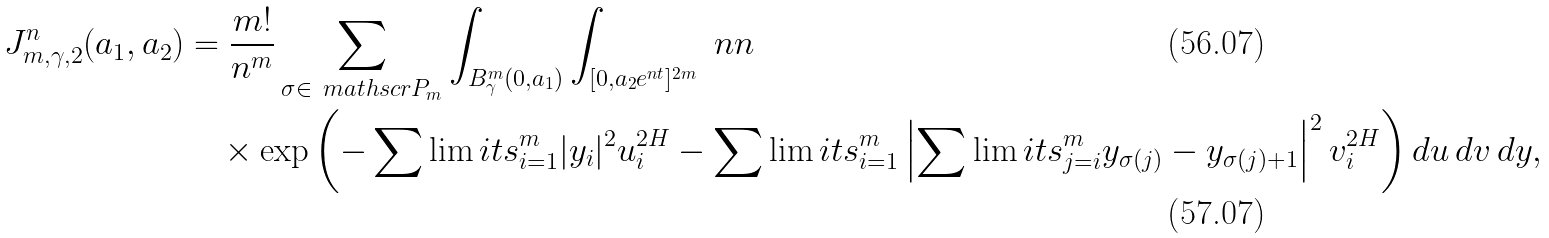Convert formula to latex. <formula><loc_0><loc_0><loc_500><loc_500>\ J ^ { n } _ { m , \gamma , 2 } ( a _ { 1 } , a _ { 2 } ) & = \frac { m ! } { n ^ { m } } \sum _ { \sigma \in \ m a t h s c r { P } _ { m } } \int _ { B ^ { m } _ { \gamma } ( 0 , a _ { 1 } ) } \int _ { [ 0 , a _ { 2 } e ^ { n t } ] ^ { 2 m } } \ n n \\ & \quad \times \exp \left ( - \sum \lim i t s ^ { m } _ { i = 1 } | y _ { i } | ^ { 2 } u _ { i } ^ { 2 H } - \sum \lim i t s ^ { m } _ { i = 1 } \left | \sum \lim i t s ^ { m } _ { j = i } y _ { \sigma ( j ) } - y _ { \sigma ( j ) + 1 } \right | ^ { 2 } v _ { i } ^ { 2 H } \right ) d u \, d v \, d y ,</formula> 